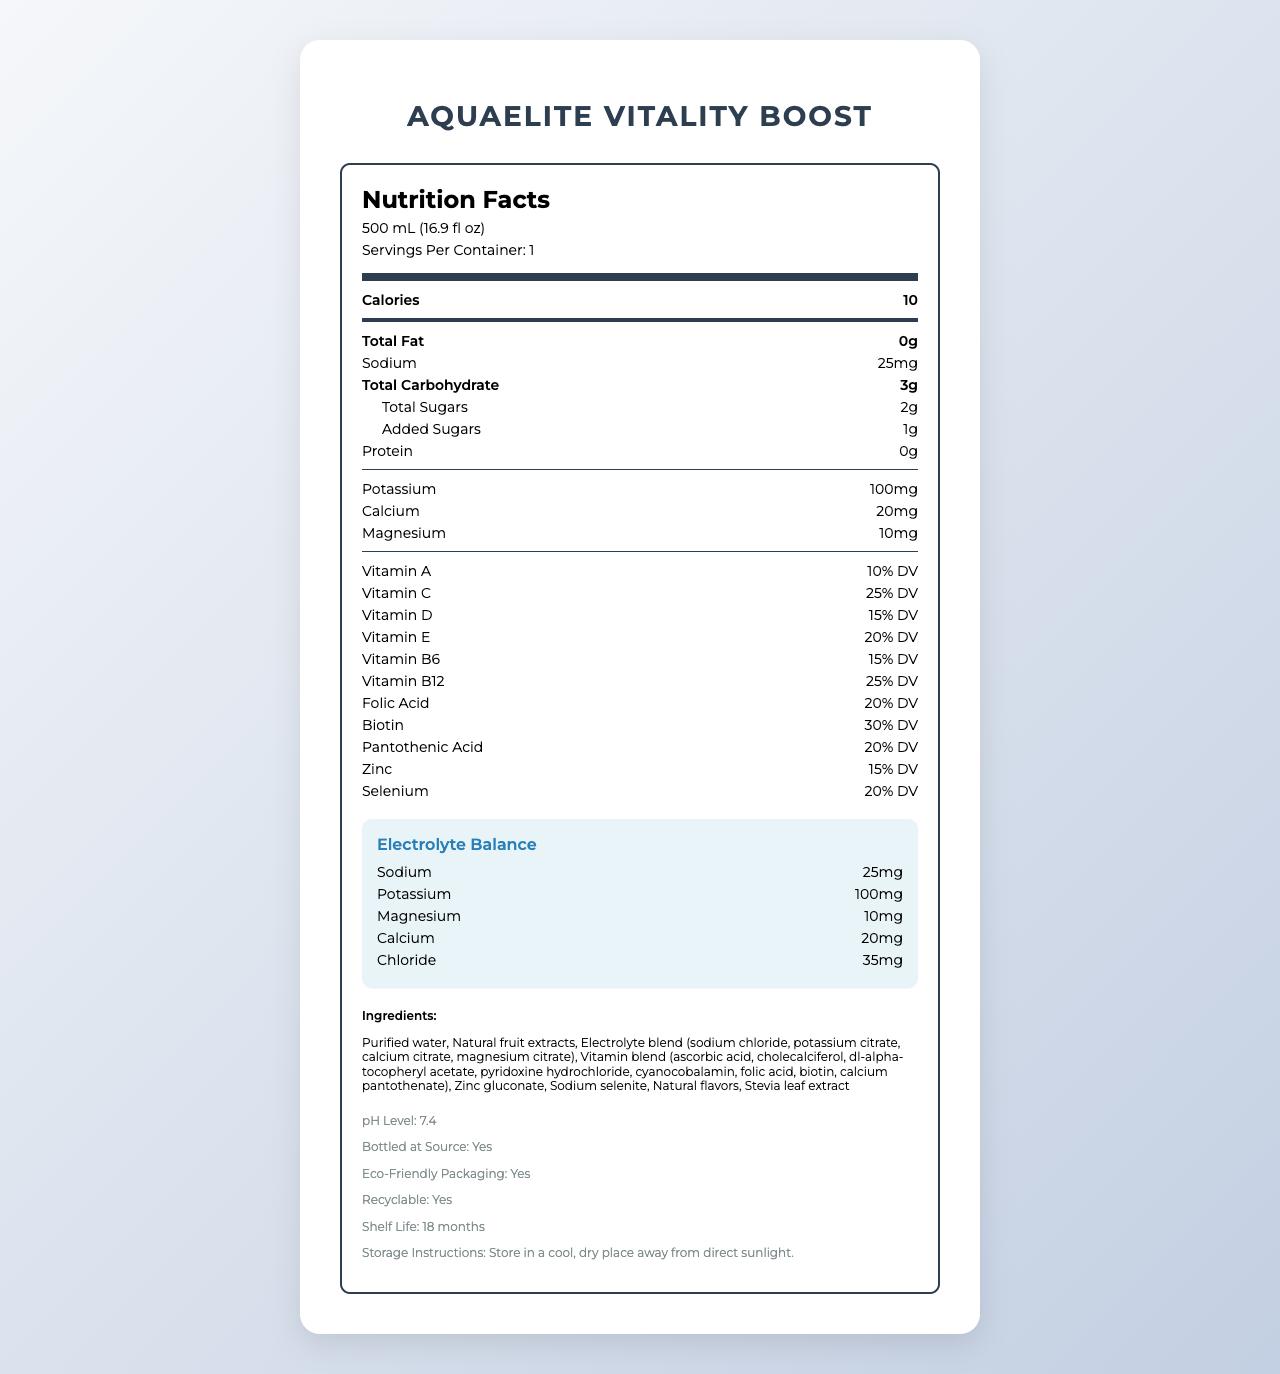what is the product name? The product name is prominently displayed at the top of the document.
Answer: AquaElite Vitality Boost what is the serving size? The serving size is listed in the "serving info" section near the top of the document.
Answer: 500 mL (16.9 fl oz) how many calories are in one serving? The calorie count is listed prominently in the "nutrition item bold" section.
Answer: 10 how much sodium is in one serving? The sodium content is listed in the "nutrition item" section.
Answer: 25mg what is the daily value percentage of Vitamin C? The daily value percentage of Vitamin C is mentioned in the "nutrition item" section in the vitamins block.
Answer: 25% DV how many servings are there per container? The number of servings per container is mentioned just below the serving size at the top of the document.
Answer: 1 what are the ingredients in this product? The ingredients are listed under the "Ingredients" section near the bottom of the document.
Answer: Purified water, Natural fruit extracts, Electrolyte blend (sodium chloride, potassium citrate, calcium citrate, magnesium citrate), Vitamin blend (ascorbic acid, cholecalciferol, dl-alpha-tocopheryl acetate, pyridoxine hydrochloride, cyanocobalamin, folic acid, biotin, calcium pantothenate), Zinc gluconate, Sodium selenite, Natural flavors, Stevia leaf extract what is the pH level of the water? The pH level is listed in the "additional info" section.
Answer: 7.4 how many certifications does this product have? The certifications section lists three distinct certifications: NSF Certified for Sport, Non-GMO Project Verified, and Informed Choice Certified.
Answer: 3 which vitamin has the highest daily value percentage in this product? A. Vitamin A B. Vitamin C C. Vitamin B12 D. Vitamin E According to the nutrition information, Vitamin B12 has the highest daily value percentage at 25%.
Answer: C. Vitamin B12 what is the electrolyte balance for potassium? A. 20mg B. 10mg C. 100mg D. 25mg The electrolyte balance section lists potassium as having 100mg.
Answer: C. 100mg is this product suitable for people with dietary restrictions like non-GMO? The document states that the product has the "Non-GMO Project Verified" certification.
Answer: Yes does the product use eco-friendly packaging? The additional info section mentions that the product has eco-friendly packaging.
Answer: Yes summarize the main features of AquaElite Vitality Boost This summary covers the primary nutritional information, certifications, packaging details, and additional features like the hydration tracking app.
Answer: AquaElite Vitality Boost is a luxury vitamin-infused bottled water with a serving size of 500 mL. It contains 10 calories per serving, with various vitamins and electrolytes, including potassium and sodium. It is NSF Certified for Sport, Non-GMO Project Verified, and Informed Choice Certified. Additionally, it is packaged in a premium glass bottle with eco-friendly features, including a tamper-evident seal and recyclable materials. The product also offers personalized hydration tracking via an app. how much chloride is in the electrolyte balance? The electrolyte balance section lists chloride as having 35mg.
Answer: 35mg who is the target audience for this product? The target audience is clearly stated in the document.
Answer: Health-conscious professionals and athletes what is the suggested retail price? The suggested retail price is given in the document.
Answer: $4.99 where is this product bottled? The document states that the product is bottled at the source but does not specify the location of the source.
Answer: Cannot be determined 